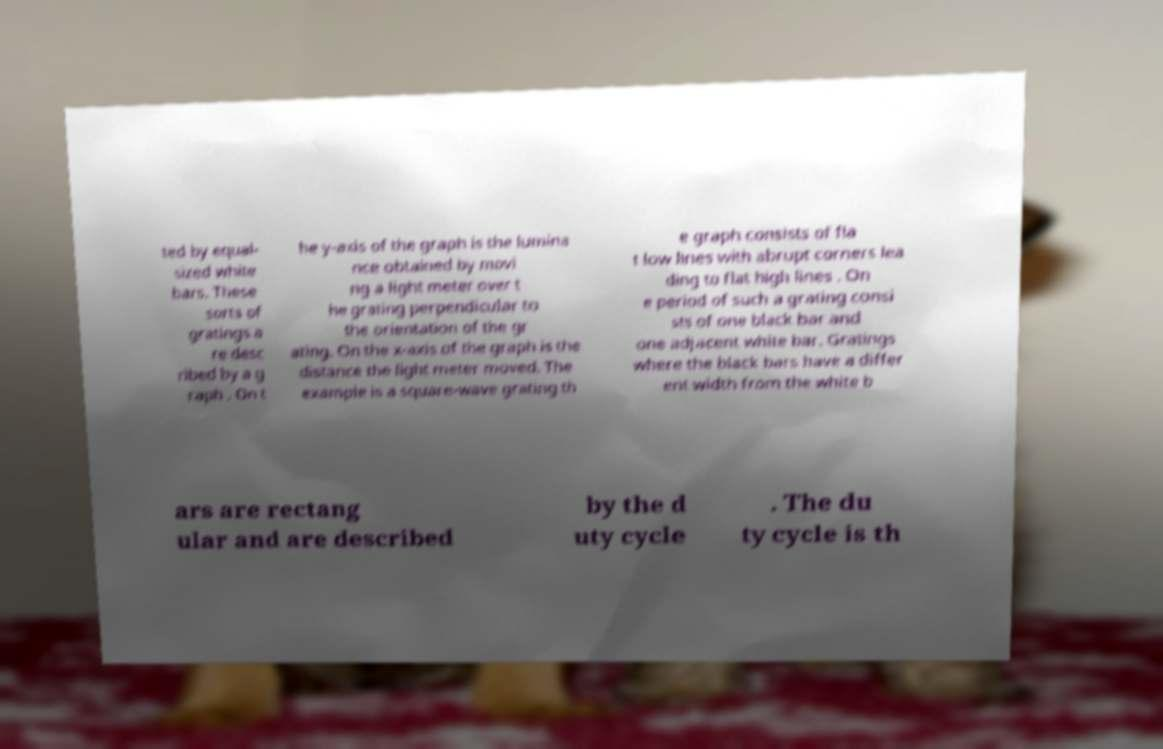Please read and relay the text visible in this image. What does it say? ted by equal- sized white bars. These sorts of gratings a re desc ribed by a g raph . On t he y-axis of the graph is the lumina nce obtained by movi ng a light meter over t he grating perpendicular to the orientation of the gr ating. On the x-axis of the graph is the distance the light meter moved. The example is a square-wave grating th e graph consists of fla t low lines with abrupt corners lea ding to flat high lines . On e period of such a grating consi sts of one black bar and one adjacent white bar. Gratings where the black bars have a differ ent width from the white b ars are rectang ular and are described by the d uty cycle . The du ty cycle is th 